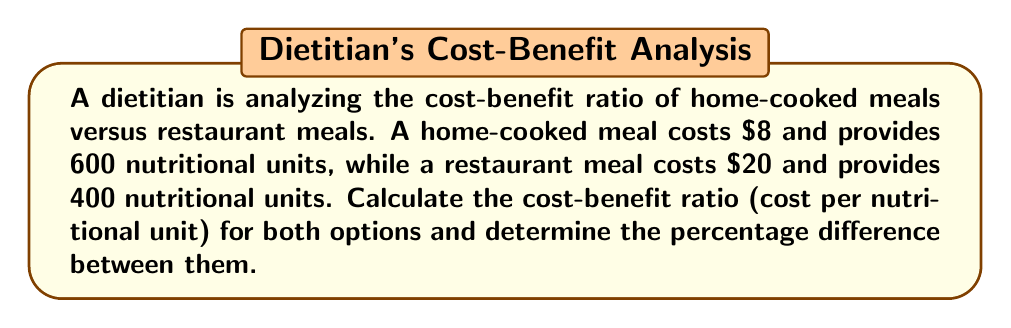Show me your answer to this math problem. Let's solve this problem step by step:

1. Calculate the cost-benefit ratio for home-cooked meals:
   $$\text{Ratio}_{\text{home}} = \frac{\text{Cost}_{\text{home}}}{\text{Nutritional units}_{\text{home}}} = \frac{\$8}{600} = \$0.0133\text{ per nutritional unit}$$

2. Calculate the cost-benefit ratio for restaurant meals:
   $$\text{Ratio}_{\text{restaurant}} = \frac{\text{Cost}_{\text{restaurant}}}{\text{Nutritional units}_{\text{restaurant}}} = \frac{\$20}{400} = \$0.05\text{ per nutritional unit}$$

3. Calculate the difference between the ratios:
   $$\text{Difference} = \text{Ratio}_{\text{restaurant}} - \text{Ratio}_{\text{home}} = \$0.05 - \$0.0133 = \$0.0367$$

4. Calculate the percentage difference:
   $$\text{Percentage difference} = \frac{\text{Difference}}{\text{Ratio}_{\text{home}}} \times 100\%$$
   $$= \frac{\$0.0367}{\$0.0133} \times 100\% = 275.94\%$$

Therefore, the cost-benefit ratio for home-cooked meals is $0.0133 per nutritional unit, and for restaurant meals is $0.05 per nutritional unit. The percentage difference between them is 275.94%.
Answer: Home-cooked: $0.0133/unit, Restaurant: $0.05/unit, 275.94% difference 